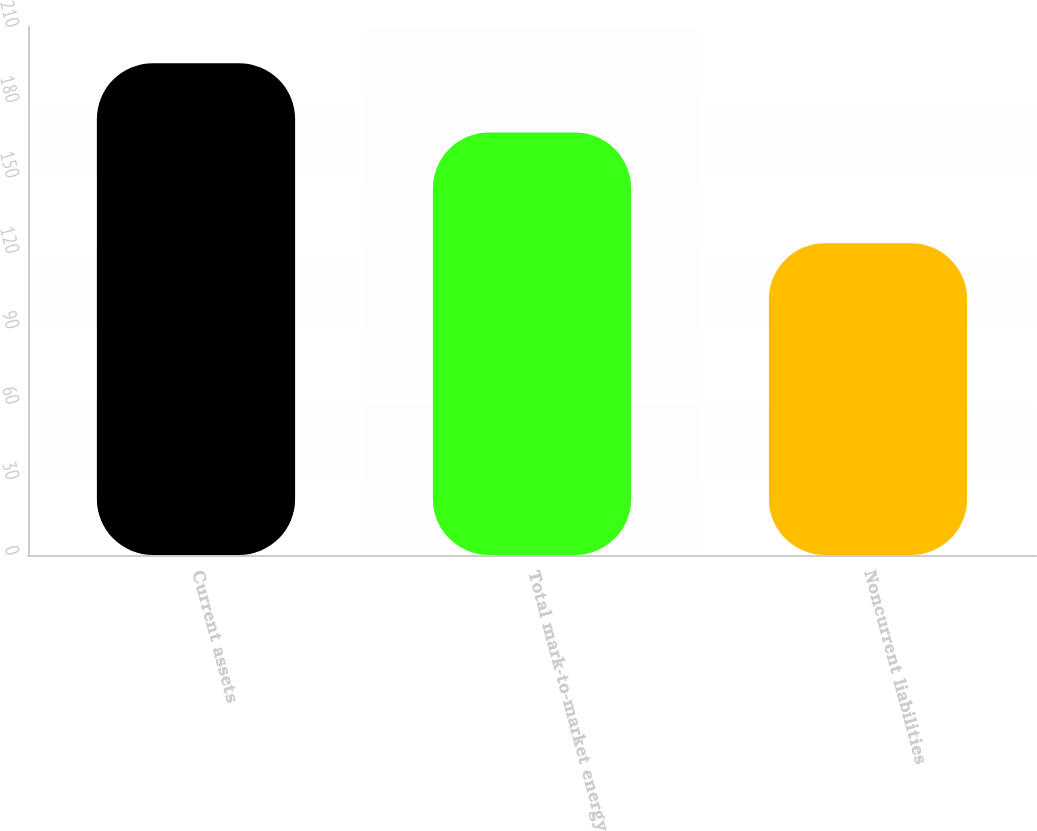<chart> <loc_0><loc_0><loc_500><loc_500><bar_chart><fcel>Current assets<fcel>Total mark-to-market energy<fcel>Noncurrent liabilities<nl><fcel>195.6<fcel>168<fcel>124<nl></chart> 